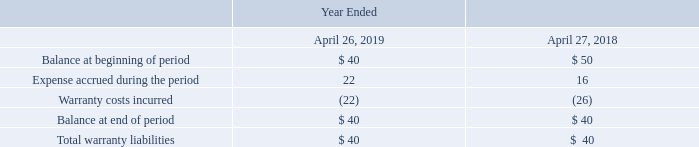Product warranty liabilities:
Equipment and software systems sales include a standard product warranty. The following tables summarize the activity related to product warranty liabilities and their balances as reported in our consolidated balance sheets (in millions):
Which years does the table provide information for the company's activity related to product warranty liabilities and their balances as reported in their consolidated balance sheets 2019, 2018. What was the Balance at beginning of period in 2019?
Answer scale should be: million. 40. What was the Expense accrued during the period in 2018?
Answer scale should be: million. 16. What was the change in expense accrued during the period between 2018 and 2019?
Answer scale should be: million. 22-16
Answer: 6. How many years did the balance at beginning of period exceed $45 million? 2018
Answer: 1. What was the percentage change in the Warranty costs incurred between 2018 and 2019?
Answer scale should be: percent. (-22-(-26))/-26
Answer: -15.38. 